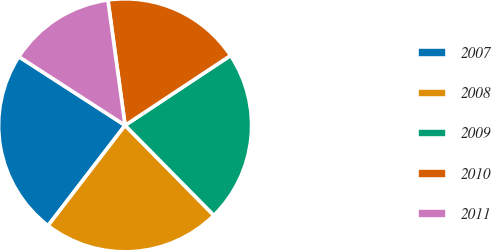Convert chart to OTSL. <chart><loc_0><loc_0><loc_500><loc_500><pie_chart><fcel>2007<fcel>2008<fcel>2009<fcel>2010<fcel>2011<nl><fcel>23.71%<fcel>22.81%<fcel>21.92%<fcel>17.86%<fcel>13.7%<nl></chart> 